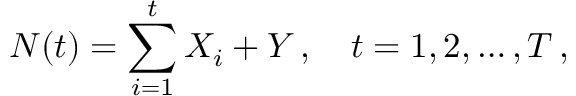<formula> <loc_0><loc_0><loc_500><loc_500>N ( t ) = \sum _ { i = 1 } ^ { t } X _ { i } + Y \, , \quad t = 1 , 2 , \dots , T \, ,</formula> 